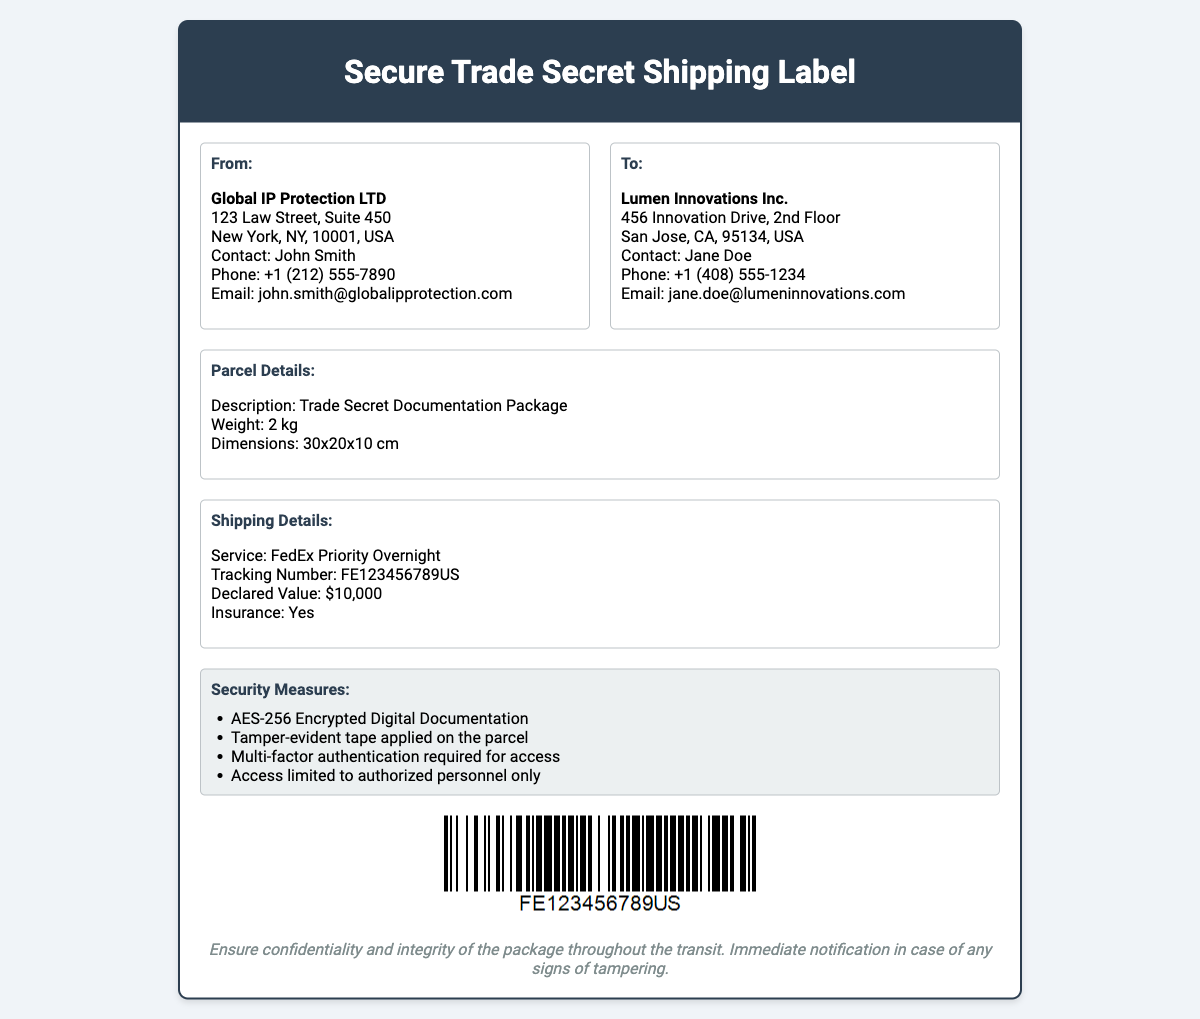What is the sender's company name? The sender's company name is mentioned in the "From" section of the document.
Answer: Global IP Protection LTD What is the recipient's address? The recipient's address can be found in the "To" section of the document.
Answer: 456 Innovation Drive, 2nd Floor, San Jose, CA, 95134, USA What is the declared value of the parcel? The declared value is specified in the "Shipping Details" section.
Answer: $10,000 What is the weight of the parcel? The weight of the parcel is listed in the "Parcel Details" section.
Answer: 2 kg What security measure involves tape? The security measures section mentions specific items that ensure security.
Answer: Tamper-evident tape applied on the parcel How many kg is the parcel? The weight of the parcel can be found in the "Parcel Details" section.
Answer: 2 kg What is the tracking number? The tracking number is provided in the "Shipping Details" section of the document.
Answer: FE123456789US Who is the contact person for the sender? The contact person for the sender is listed in the "From" section.
Answer: John Smith What type of service is used for shipping? The type of service used for shipping is detailed in the "Shipping Details" section of the document.
Answer: FedEx Priority Overnight 